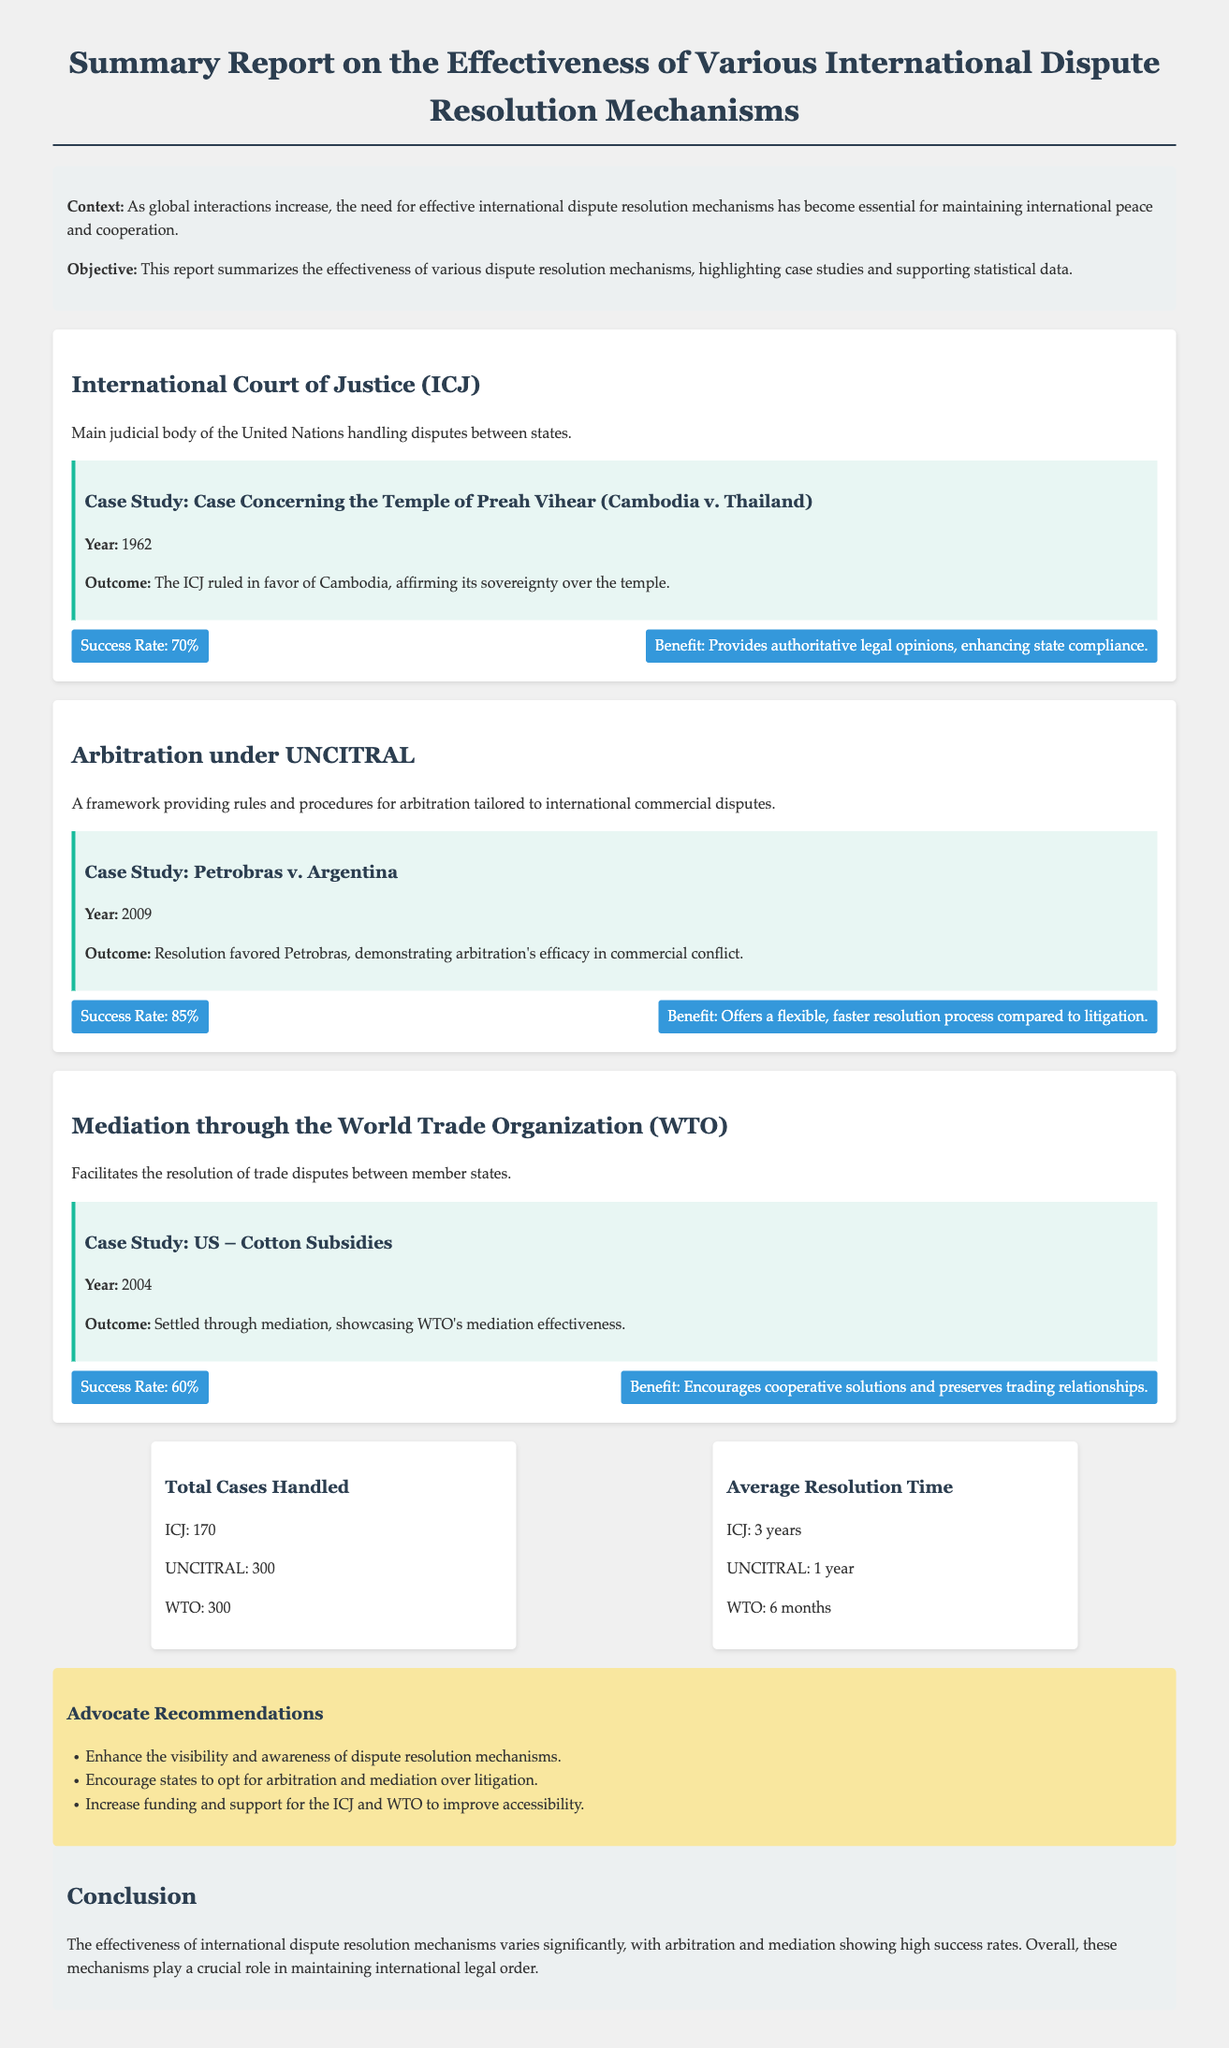What is the main judicial body of the United Nations? The main judicial body of the United Nations handling disputes between states is the International Court of Justice.
Answer: International Court of Justice What was the outcome of the case concerning the Temple of Preah Vihear? The ICJ ruled in favor of Cambodia, affirming its sovereignty over the temple.
Answer: Ruling in favor of Cambodia What is the success rate of arbitration under UNCITRAL? The success rate of arbitration under UNCITRAL is highlighted as a key statistic in the report.
Answer: 85% How long does it typically take to resolve a dispute through the WTO? The average resolution time for disputes through the World Trade Organization is mentioned in the statistics section.
Answer: 6 months What year did the case of Petrobras v. Argentina take place? The year of the case Petrobras v. Argentina is provided in the case study section.
Answer: 2009 Which dispute resolution mechanism had the highest total cases handled? The document outlines the number of total cases handled by various mechanisms, comparing them.
Answer: UNCITRAL What do the recommendations advocate for regarding dispute resolution mechanisms? The recommendations suggest several actions to improve international dispute resolution mechanisms.
Answer: Enhance visibility and awareness What is the effectiveness rate of mediation through the WTO? The effectiveness of mediation through WTO is expressed as a success rate in the report.
Answer: 60% 